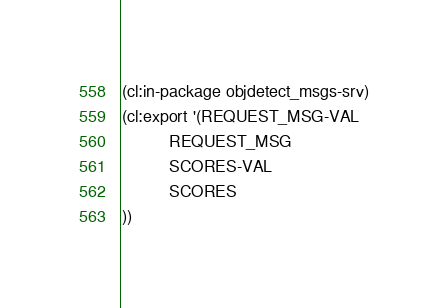Convert code to text. <code><loc_0><loc_0><loc_500><loc_500><_Lisp_>(cl:in-package objdetect_msgs-srv)
(cl:export '(REQUEST_MSG-VAL
          REQUEST_MSG
          SCORES-VAL
          SCORES
))</code> 